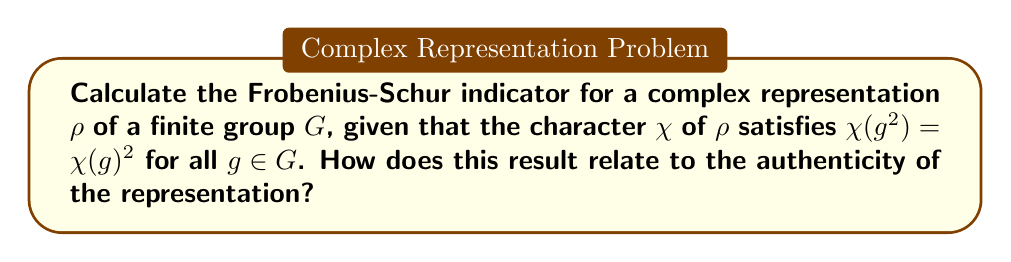Could you help me with this problem? Let's approach this step-by-step:

1) The Frobenius-Schur indicator $\nu(\rho)$ for a complex representation $\rho$ of a finite group $G$ is given by:

   $$\nu(\rho) = \frac{1}{|G|} \sum_{g \in G} \chi(g^2)$$

   where $\chi$ is the character of $\rho$ and $|G|$ is the order of the group.

2) We are given that $\chi(g^2) = \chi(g)^2$ for all $g \in G$. Let's substitute this into our formula:

   $$\nu(\rho) = \frac{1}{|G|} \sum_{g \in G} \chi(g)^2$$

3) This sum is actually a well-known quantity in representation theory. It's called the second orthogonality relation and is equal to $|G|$ for any irreducible representation.

4) Therefore:

   $$\nu(\rho) = \frac{1}{|G|} \cdot |G| = 1$$

5) The Frobenius-Schur indicator can only take values in $\{-1, 0, 1\}$. A value of 1 indicates that the representation is orthogonal (real).

6) This result relates to authenticity in that it shows the representation is genuinely real, despite being given as a complex representation. In the context of our persona, this mirrors how an individual's authentic story can shine through, even when presented through the lens of a filmmaker's work.
Answer: $\nu(\rho) = 1$ 